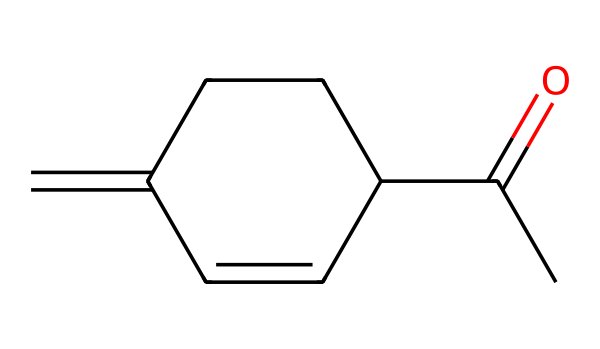What is the functional group present in jasmone? The functional group in jasmone is characterized by a carbonyl group (C=O). In the structural formula, this is seen at the acetyl (CC(=O)) part of the molecule.
Answer: carbonyl How many carbon atoms are in jasmone? Counting from the SMILES representation, there are 10 carbon atoms total, consisting of those in the ring and the chain.
Answer: ten What type of chemical is jasmone classified as? Jasmone is classified as a ketone. This classification is based on the presence of the carbonyl group between two carbon atoms in the structure.
Answer: ketone How many double bonds are present in jasmone? There are three double bonds present in jasmone, which can be counted in the structure of the ring and the carbonyl group.
Answer: three What is the significance of the carbonyl group in jasmone? The carbonyl group in jasmone affects its reactivity and contributes to its aroma, making it significant in the context of fragrance. Ketones often influence mood and perception.
Answer: aroma What would be the impact of jasmone on mood? Jasmone, being associated with the scent of jasmine flowers, is known to have a soothing effect and often helps reduce stress and anxiety, contributing positively to mood enhancement.
Answer: soothing effect 